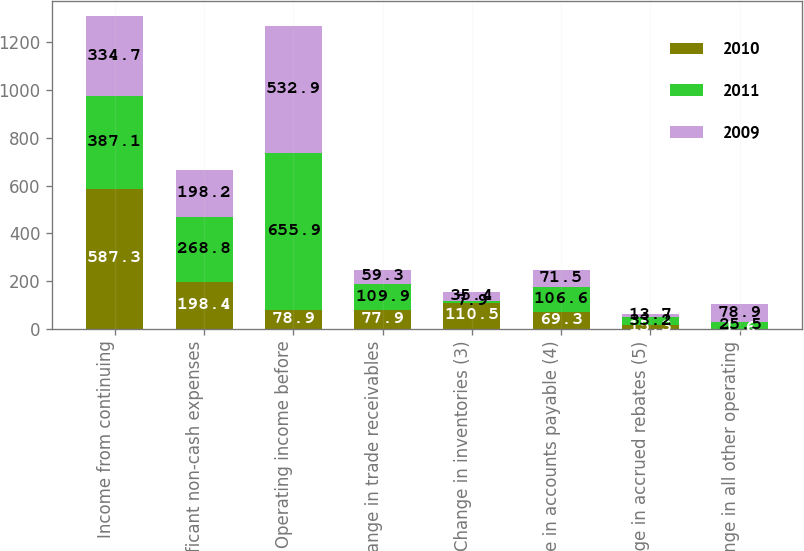Convert chart to OTSL. <chart><loc_0><loc_0><loc_500><loc_500><stacked_bar_chart><ecel><fcel>Income from continuing<fcel>Significant non-cash expenses<fcel>Operating income before<fcel>Change in trade receivables<fcel>Change in inventories (3)<fcel>Change in accounts payable (4)<fcel>Change in accrued rebates (5)<fcel>Change in all other operating<nl><fcel>2010<fcel>587.3<fcel>198.4<fcel>78.9<fcel>77.9<fcel>110.5<fcel>69.3<fcel>15.3<fcel>1.6<nl><fcel>2011<fcel>387.1<fcel>268.8<fcel>655.9<fcel>109.9<fcel>7.9<fcel>106.6<fcel>33.2<fcel>25.5<nl><fcel>2009<fcel>334.7<fcel>198.2<fcel>532.9<fcel>59.3<fcel>35.4<fcel>71.5<fcel>13.7<fcel>78.9<nl></chart> 